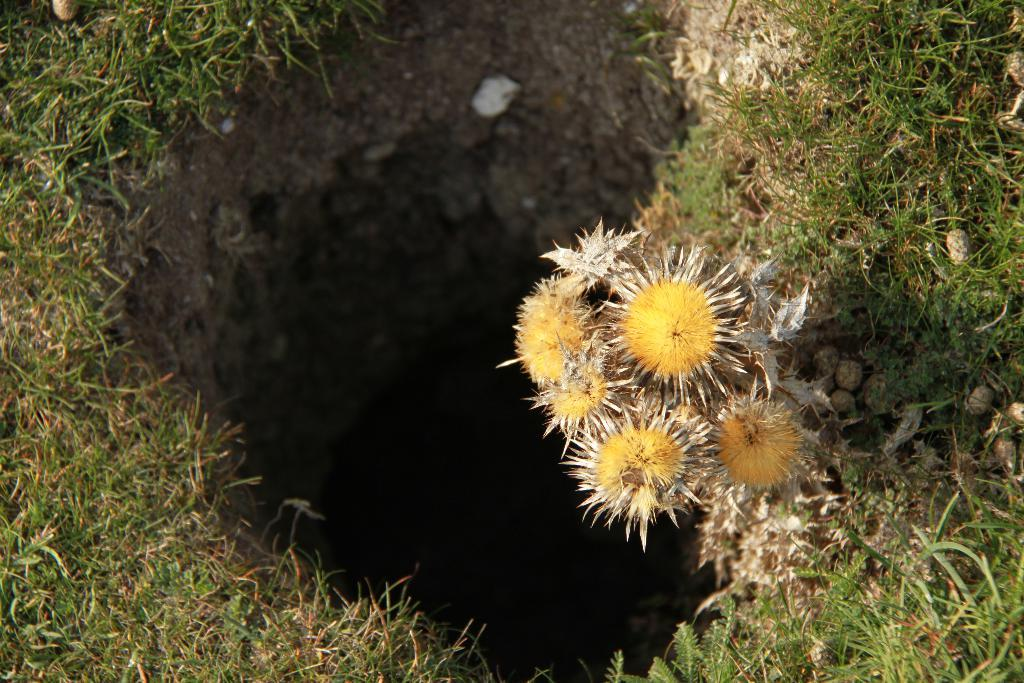What type of plants can be seen in the image? There are flowers in the image. What other natural elements are present in the image? There are stones and grass in the image. Can you describe any man-made structures in the image? There is a burrow in the image. What type of plantation can be seen in the image? There is no plantation present in the image; it features flowers, stones, grass, and a burrow. What disease affects the flowers in the image? There is no indication of any disease affecting the flowers in the image. 